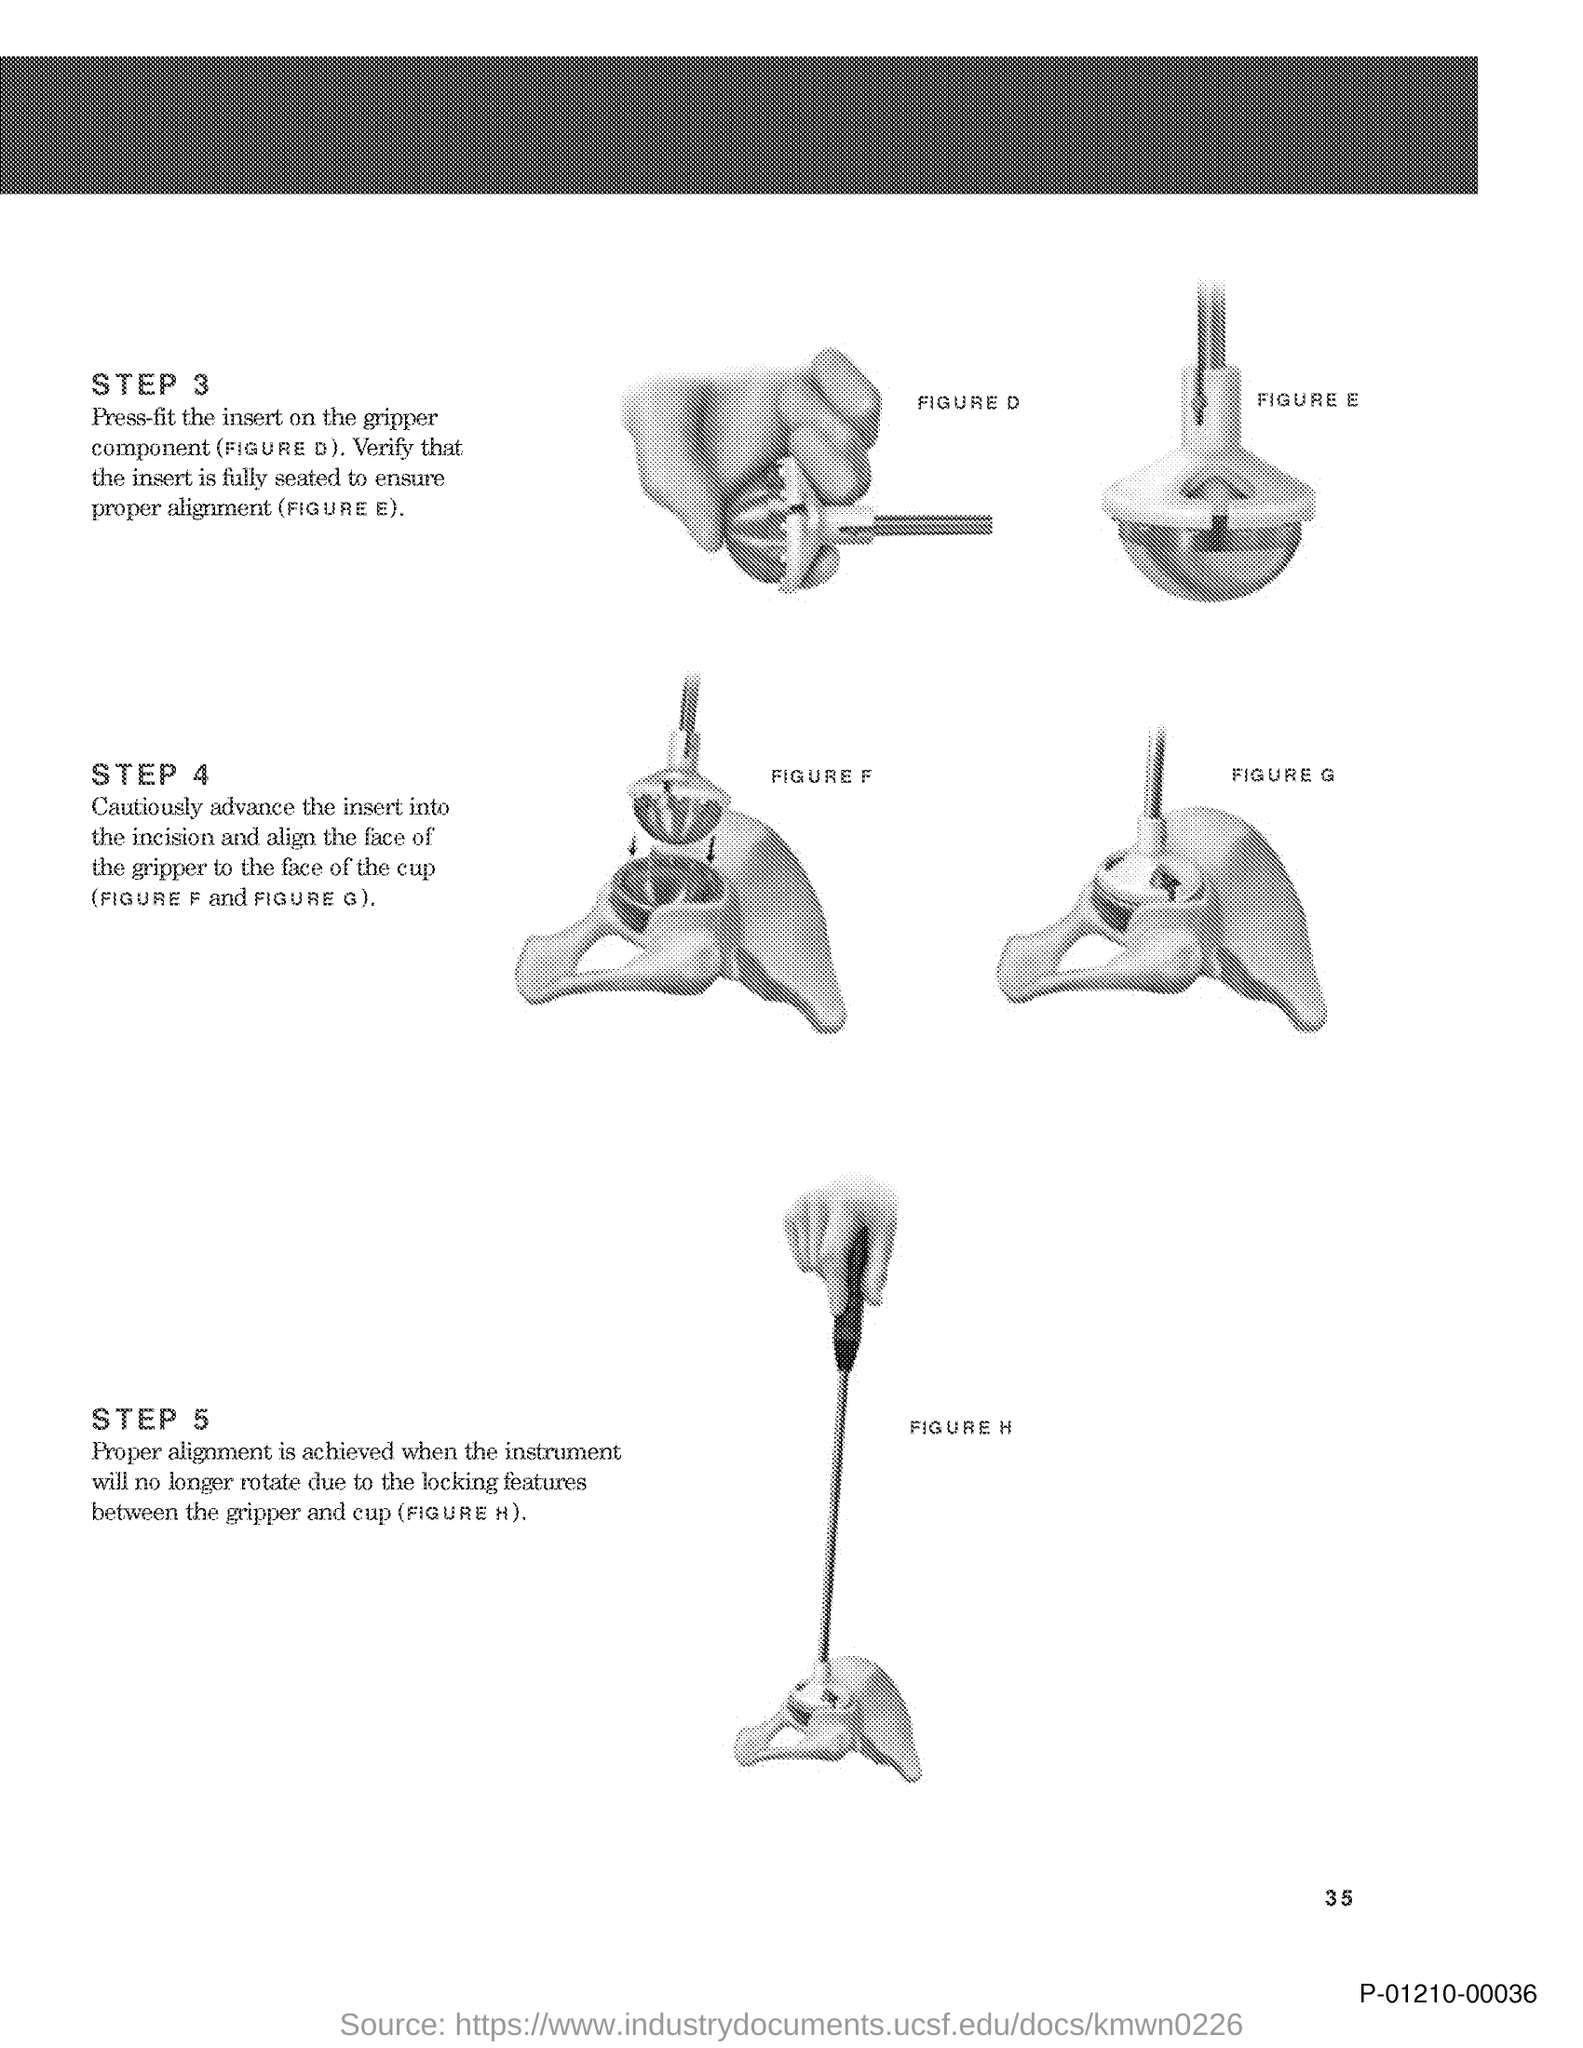What is the figure D about?
Provide a short and direct response. Press-fit the insert on the gripper component. What is the code at the bottom right corner of the page?
Offer a very short reply. P-01210-00036. What is the page number on this document?
Keep it short and to the point. 35. Which figure says "Verify that the insert is fully seated to ensure proper alignment"?
Your answer should be very brief. (FIGURE E). 